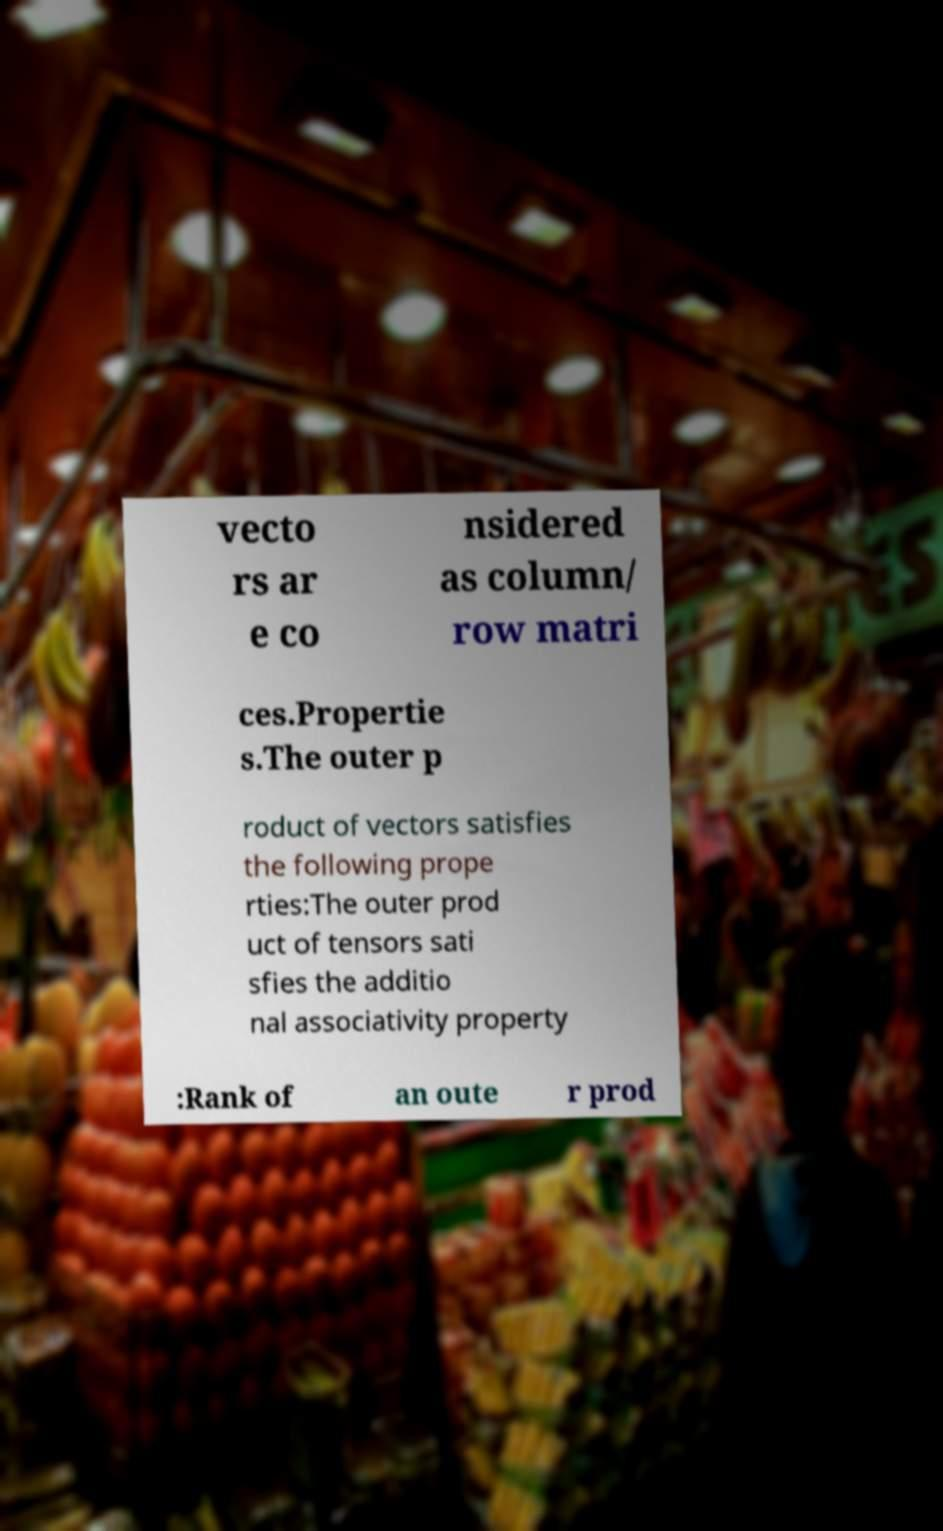Please identify and transcribe the text found in this image. vecto rs ar e co nsidered as column/ row matri ces.Propertie s.The outer p roduct of vectors satisfies the following prope rties:The outer prod uct of tensors sati sfies the additio nal associativity property :Rank of an oute r prod 